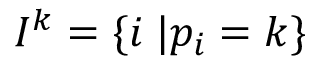<formula> <loc_0><loc_0><loc_500><loc_500>I ^ { k } = \{ i \, | p _ { i } = k \}</formula> 